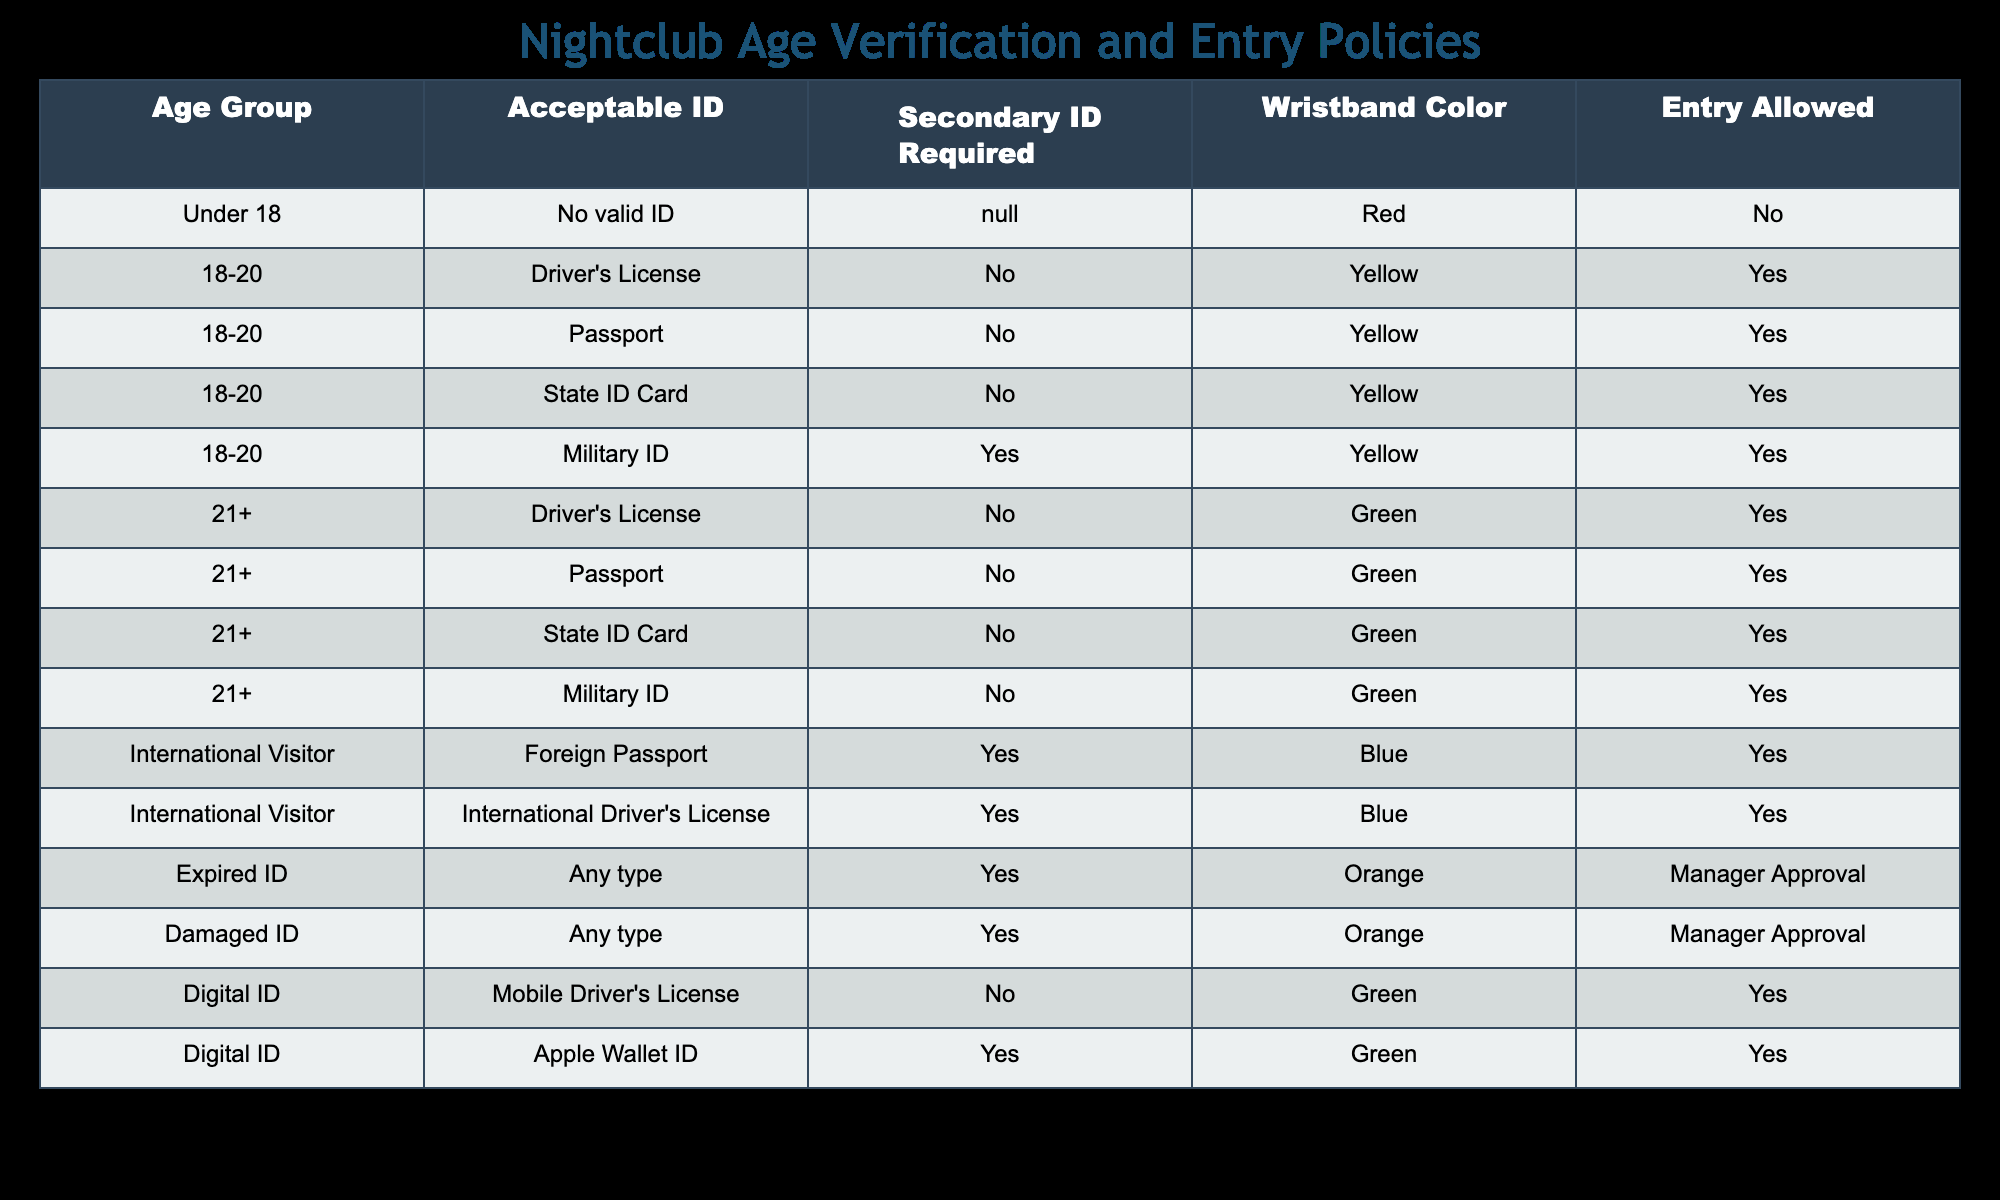What wristband color is assigned to someone aged 18-20 with a military ID? The table indicates that individuals in the age group 18-20 with a military ID are assigned a wristband color of yellow.
Answer: Yellow Can someone entry under 18 years old with no valid ID? According to the table, entry is not allowed for individuals under 18 years who do not have valid ID.
Answer: No How many different types of acceptable IDs are listed for the age group 21+? The table lists four types of acceptable IDs for the age group 21+, which are Driver's License, Passport, State ID Card, and Military ID.
Answer: Four Is a mobile driver's license an acceptable ID for digital identification? Yes, the table states that a mobile driver's license is an acceptable form of ID for digital identification without a secondary ID required.
Answer: Yes If an international visitor presents an expired passport, can they enter the nightclub? The table specifies that for international visitors, a foreign passport is required, and since an expired passport does not meet this requirement, they cannot enter.
Answer: No What percentage of acceptable IDs for the age group 18-20 requires a secondary ID? Out of the four acceptable IDs for the age group 18-20, only the military ID requires a secondary ID, making it 25% (1 out of 4).
Answer: 25% How many total types of ID require manager approval for entry? The table shows that both expired IDs and damaged IDs require manager approval, totaling two types of IDs that need this approval for entry.
Answer: Two For international visitors, what is the wristband color associated with foreign passports? The table notes that international visitors using a foreign passport receive a blue wristband.
Answer: Blue What is the total number of different age groups listed in the table, including international visitors? There are five distinct age groups mentioned in the table: Under 18, 18-20, 21+, International Visitor, and Expired ID, summing to five age groups total.
Answer: Five 